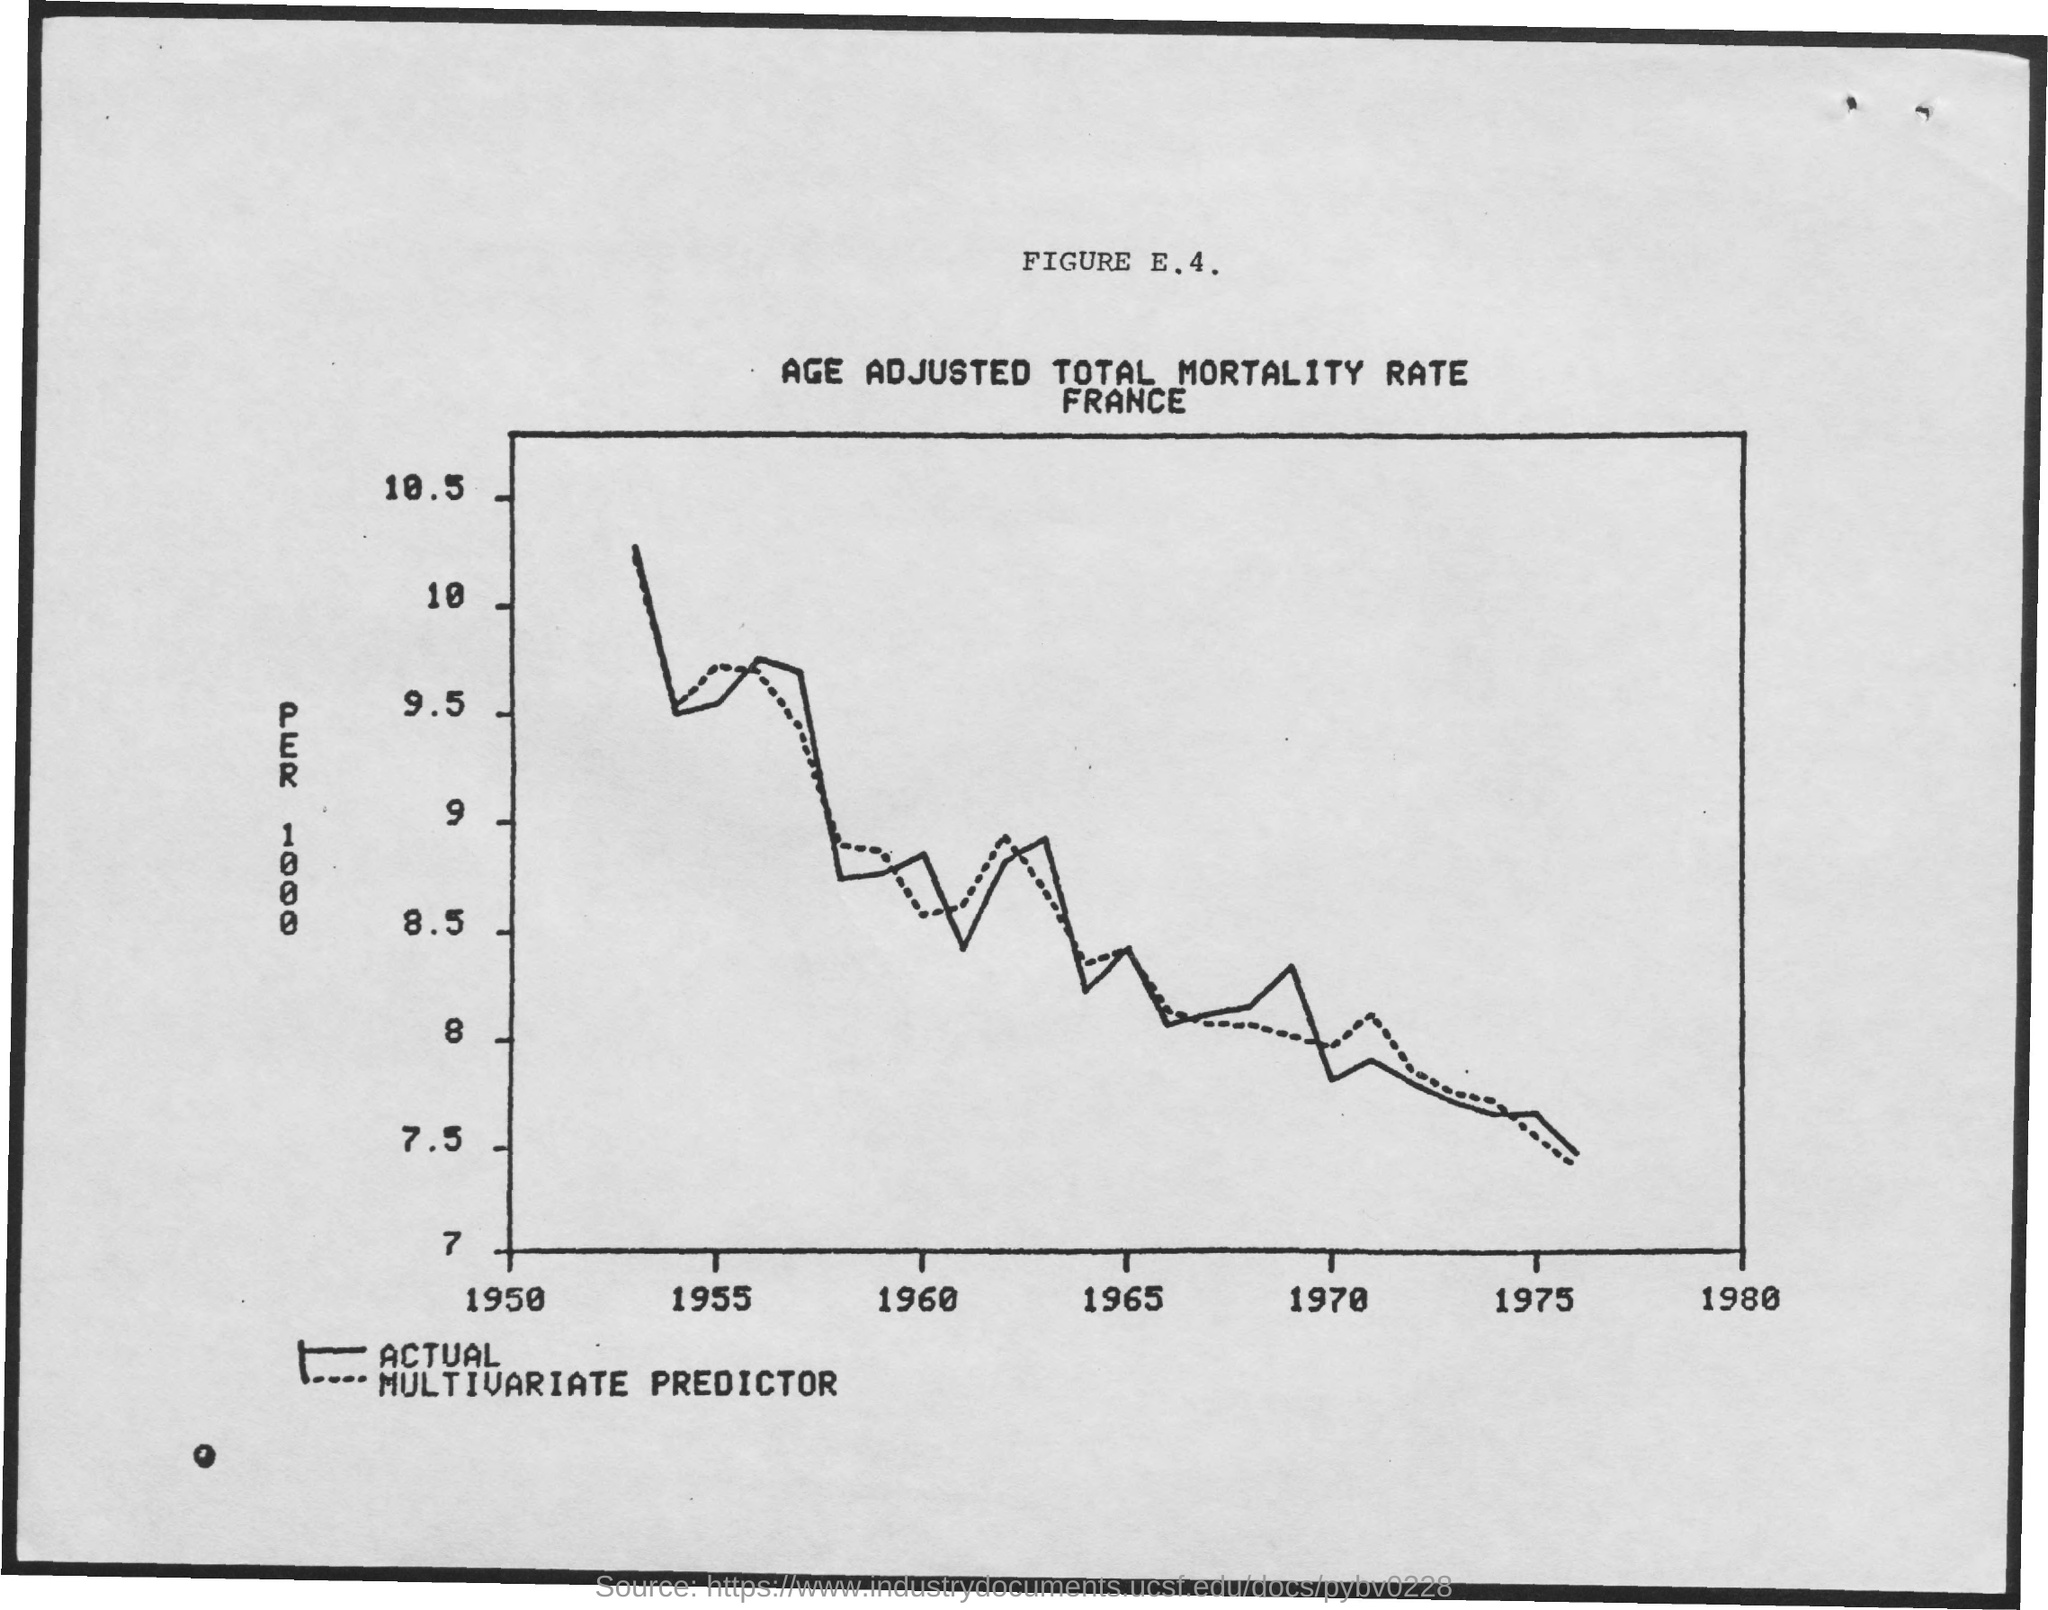Which year is mentioned first in the x axis?
Your answer should be compact. 1950. 